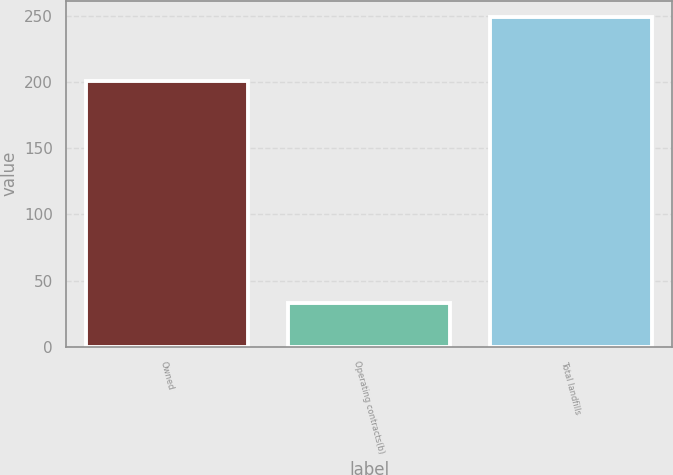Convert chart. <chart><loc_0><loc_0><loc_500><loc_500><bar_chart><fcel>Owned<fcel>Operating contracts(b)<fcel>Total landfills<nl><fcel>201<fcel>33<fcel>249<nl></chart> 